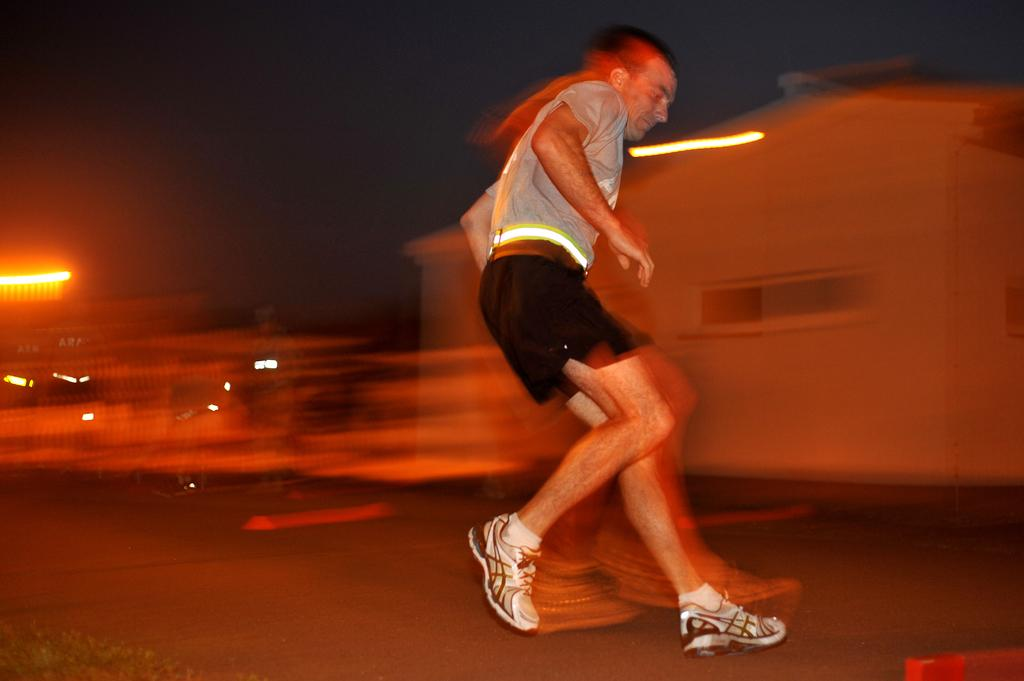What is the main subject of the image? There is a man in the image. What is the man wearing? The man is wearing a grey t-shirt and shorts. What is the man doing in the image? The man is running on the road. What can be seen in the background of the image? There is a building with lights in the background. When was the image taken? The image was taken at night time. What type of dinner is the man eating in the image? There is no dinner present in the image; the man is running on the road. What material is used to cover the man in the image? The man is not covered by any material in the image; he is wearing a grey t-shirt and shorts. 